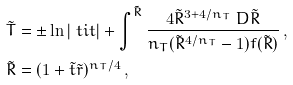Convert formula to latex. <formula><loc_0><loc_0><loc_500><loc_500>& \tilde { T } = \pm \ln | \ t i t | + \int ^ { \tilde { R } } \frac { 4 \tilde { R } ^ { 3 + 4 / n _ { T } } \ D \tilde { R } } { n _ { T } ( \tilde { R } ^ { 4 / n _ { T } } - 1 ) f ( \tilde { R } ) } \, , \\ & \tilde { R } = ( 1 + \tilde { t } \tilde { r } ) ^ { n _ { T } / 4 } \, ,</formula> 